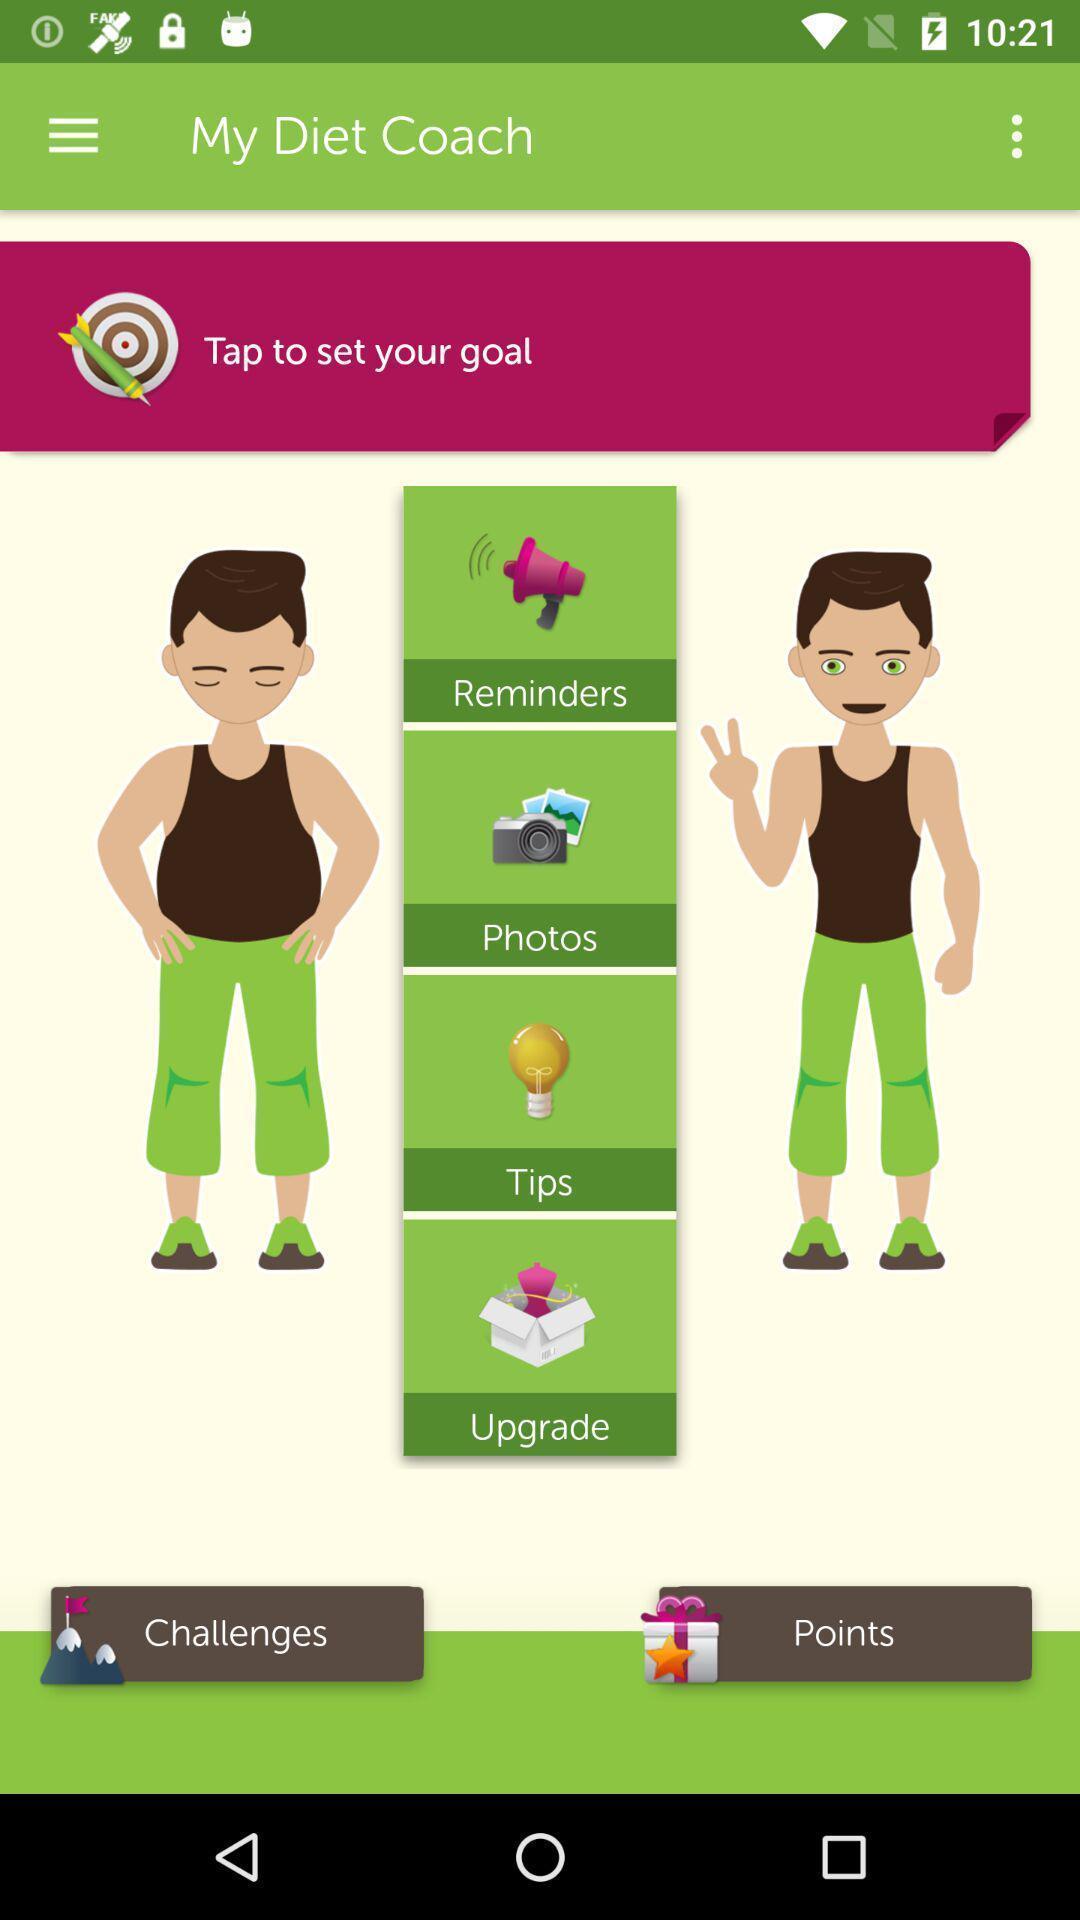Please provide a description for this image. Page displays different options in the diet plan app. 